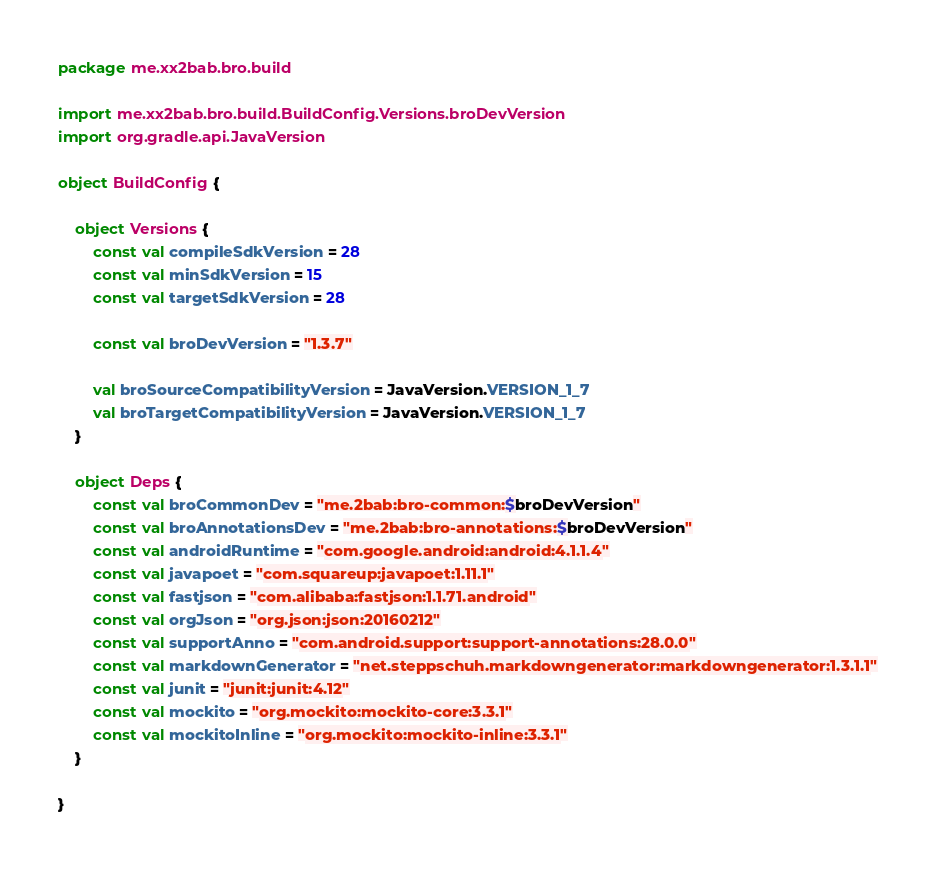<code> <loc_0><loc_0><loc_500><loc_500><_Kotlin_>package me.xx2bab.bro.build

import me.xx2bab.bro.build.BuildConfig.Versions.broDevVersion
import org.gradle.api.JavaVersion

object BuildConfig {

    object Versions {
        const val compileSdkVersion = 28
        const val minSdkVersion = 15
        const val targetSdkVersion = 28

        const val broDevVersion = "1.3.7"

        val broSourceCompatibilityVersion = JavaVersion.VERSION_1_7
        val broTargetCompatibilityVersion = JavaVersion.VERSION_1_7
    }

    object Deps {
        const val broCommonDev = "me.2bab:bro-common:$broDevVersion"
        const val broAnnotationsDev = "me.2bab:bro-annotations:$broDevVersion"
        const val androidRuntime = "com.google.android:android:4.1.1.4"
        const val javapoet = "com.squareup:javapoet:1.11.1"
        const val fastjson = "com.alibaba:fastjson:1.1.71.android"
        const val orgJson = "org.json:json:20160212"
        const val supportAnno = "com.android.support:support-annotations:28.0.0"
        const val markdownGenerator = "net.steppschuh.markdowngenerator:markdowngenerator:1.3.1.1"
        const val junit = "junit:junit:4.12"
        const val mockito = "org.mockito:mockito-core:3.3.1"
        const val mockitoInline = "org.mockito:mockito-inline:3.3.1"
    }

}</code> 